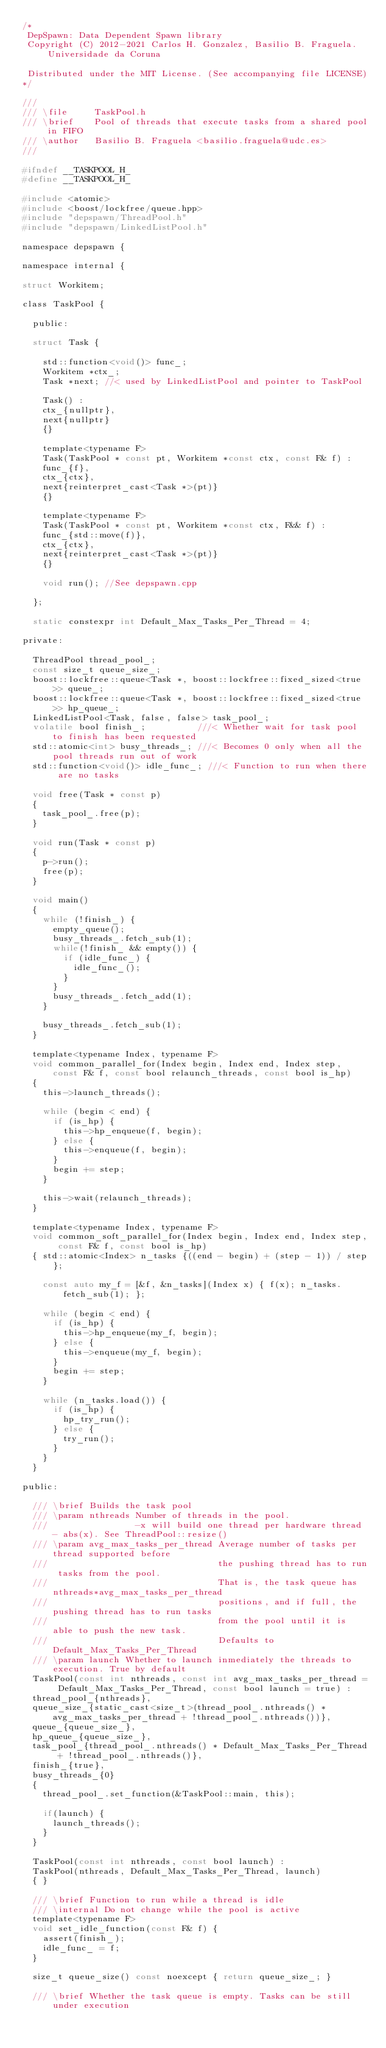Convert code to text. <code><loc_0><loc_0><loc_500><loc_500><_C_>/*
 DepSpawn: Data Dependent Spawn library
 Copyright (C) 2012-2021 Carlos H. Gonzalez, Basilio B. Fraguela. Universidade da Coruna
 
 Distributed under the MIT License. (See accompanying file LICENSE)
*/

///
/// \file     TaskPool.h
/// \brief    Pool of threads that execute tasks from a shared pool in FIFO
/// \author   Basilio B. Fraguela <basilio.fraguela@udc.es>
///

#ifndef __TASKPOOL_H_
#define __TASKPOOL_H_

#include <atomic>
#include <boost/lockfree/queue.hpp>
#include "depspawn/ThreadPool.h"
#include "depspawn/LinkedListPool.h"

namespace depspawn {

namespace internal {

struct Workitem;

class TaskPool {

  public:
  
  struct Task {

    std::function<void()> func_;
    Workitem *ctx_;
    Task *next; //< used by LinkedListPool and pointer to TaskPool
    
    Task() :
    ctx_{nullptr},
    next{nullptr}
    {}
    
    template<typename F>
    Task(TaskPool * const pt, Workitem *const ctx, const F& f) :
    func_{f},
    ctx_{ctx},
    next{reinterpret_cast<Task *>(pt)}
    {}

    template<typename F>
    Task(TaskPool * const pt, Workitem *const ctx, F&& f) :
    func_{std::move(f)},
    ctx_{ctx},
    next{reinterpret_cast<Task *>(pt)}
    {}

    void run(); //See depspawn.cpp

  };

  static constexpr int Default_Max_Tasks_Per_Thread = 4;

private:
  
  ThreadPool thread_pool_;
  const size_t queue_size_;
  boost::lockfree::queue<Task *, boost::lockfree::fixed_sized<true>> queue_;
  boost::lockfree::queue<Task *, boost::lockfree::fixed_sized<true>> hp_queue_;
  LinkedListPool<Task, false, false> task_pool_;
  volatile bool finish_;          ///< Whether wait for task pool to finish has been requested
  std::atomic<int> busy_threads_; ///< Becomes 0 only when all the pool threads run out of work
  std::function<void()> idle_func_; ///< Function to run when there are no tasks

  void free(Task * const p)
  {
    task_pool_.free(p);
  }

  void run(Task * const p)
  {
    p->run();
    free(p);
  }

  void main()
  {
    while (!finish_) {
      empty_queue();
      busy_threads_.fetch_sub(1);
      while(!finish_ && empty()) {
        if (idle_func_) {
          idle_func_();
        }
      }
      busy_threads_.fetch_add(1);
    }

    busy_threads_.fetch_sub(1);
  }

  template<typename Index, typename F>
  void common_parallel_for(Index begin, Index end, Index step, const F& f, const bool relaunch_threads, const bool is_hp)
  {
    this->launch_threads();

    while (begin < end) {
      if (is_hp) {
        this->hp_enqueue(f, begin);
      } else {
        this->enqueue(f, begin);
      }
      begin += step;
    }

    this->wait(relaunch_threads);
  }

  template<typename Index, typename F>
  void common_soft_parallel_for(Index begin, Index end, Index step, const F& f, const bool is_hp)
  { std::atomic<Index> n_tasks {((end - begin) + (step - 1)) / step};

    const auto my_f = [&f, &n_tasks](Index x) { f(x); n_tasks.fetch_sub(1); };

    while (begin < end) {
      if (is_hp) {
        this->hp_enqueue(my_f, begin);
      } else {
        this->enqueue(my_f, begin);
      }
      begin += step;
    }

    while (n_tasks.load()) {
      if (is_hp) {
        hp_try_run();
      } else {
        try_run();
      }
    }
  }

public:

  /// \brief Builds the task pool
  /// \param nthreads Number of threads in the pool.
  ///                 -x will build one thread per hardware thread - abs(x). See ThreadPool::resize()
  /// \param avg_max_tasks_per_thread Average number of tasks per thread supported before
  ///                                 the pushing thread has to run tasks from the pool.
  ///                                 That is, the task queue has nthreads*avg_max_tasks_per_thread
  ///                                 positions, and if full, the pushing thread has to run tasks
  ///                                 from the pool until it is able to push the new task.
  ///                                 Defaults to Default_Max_Tasks_Per_Thread
  /// \param launch Whether to launch inmediately the threads to execution. True by default
  TaskPool(const int nthreads, const int avg_max_tasks_per_thread = Default_Max_Tasks_Per_Thread, const bool launch = true) :
  thread_pool_{nthreads},
  queue_size_{static_cast<size_t>(thread_pool_.nthreads() * avg_max_tasks_per_thread + !thread_pool_.nthreads())},
  queue_{queue_size_},
  hp_queue_{queue_size_},
  task_pool_{thread_pool_.nthreads() * Default_Max_Tasks_Per_Thread + !thread_pool_.nthreads()},
  finish_{true},
  busy_threads_{0}
  {
    thread_pool_.set_function(&TaskPool::main, this);

    if(launch) {
      launch_threads();
    }
  }

  TaskPool(const int nthreads, const bool launch) :
  TaskPool(nthreads, Default_Max_Tasks_Per_Thread, launch)
  { }

  /// \brief Function to run while a thread is idle
  /// \internal Do not change while the pool is active
  template<typename F>
  void set_idle_function(const F& f) {
    assert(finish_);
    idle_func_ = f;
  }

  size_t queue_size() const noexcept { return queue_size_; }

  /// \brief Whether the task queue is empty. Tasks can be still under execution</code> 